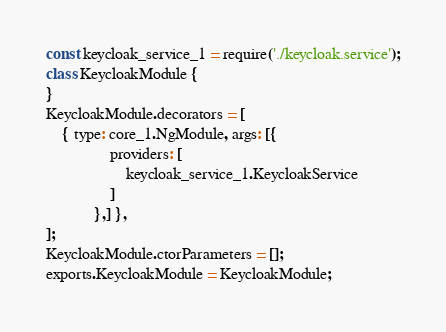<code> <loc_0><loc_0><loc_500><loc_500><_JavaScript_>const keycloak_service_1 = require('./keycloak.service');
class KeycloakModule {
}
KeycloakModule.decorators = [
    { type: core_1.NgModule, args: [{
                providers: [
                    keycloak_service_1.KeycloakService
                ]
            },] },
];
KeycloakModule.ctorParameters = [];
exports.KeycloakModule = KeycloakModule;
</code> 